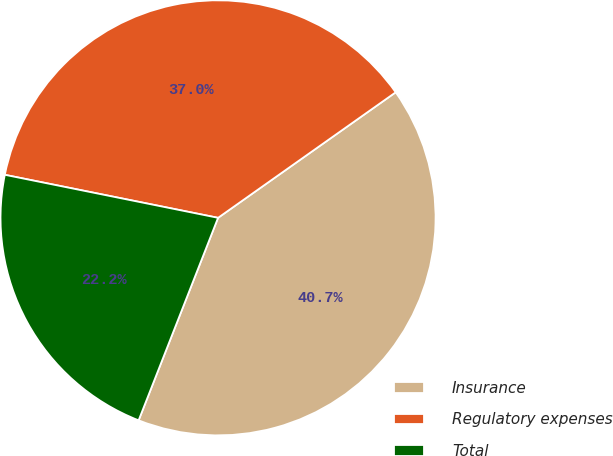<chart> <loc_0><loc_0><loc_500><loc_500><pie_chart><fcel>Insurance<fcel>Regulatory expenses<fcel>Total<nl><fcel>40.74%<fcel>37.04%<fcel>22.22%<nl></chart> 